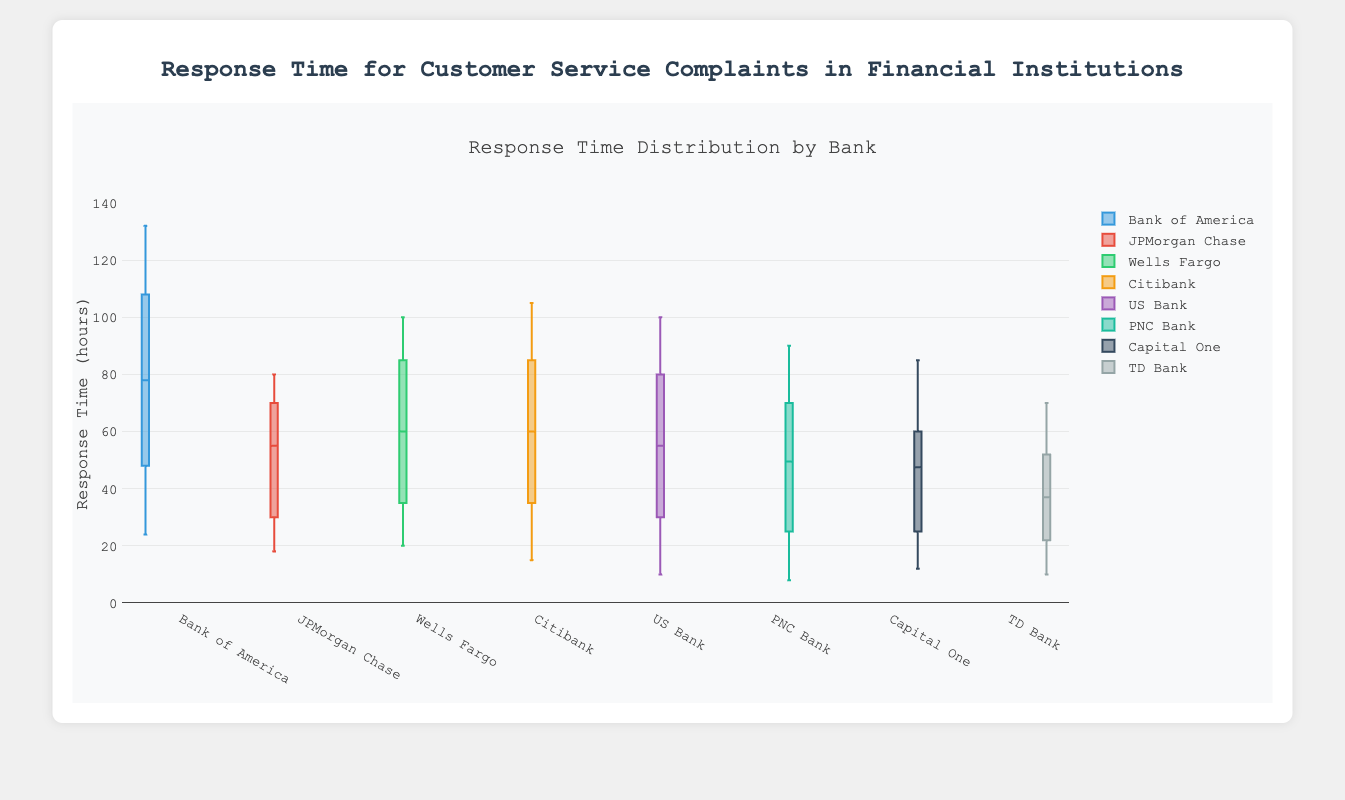How many banks are being compared in the box plot? The box plot consists of one trace for each bank, representing its response time distribution. By counting the traces, we determine that there are eight banks being compared.
Answer: Eight What is the title of the box plot? The title of the box plot is displayed at the top of the plot. It reads: "Response Time Distribution by Bank."
Answer: Response Time Distribution by Bank Which bank has the widest range of response times? To determine the bank with the widest range, compare the difference between the maximum and minimum response times for each bank. Bank of America has the widest range (from 24 to 132 hours).
Answer: Bank of America What is the median response time for Citibank? Identify the median on the box plot for Citibank, which is indicated by the central line dividing the box into two equal halves. The median response time for Citibank is 55 hours.
Answer: 55 Which bank has the shortest median response time? Compare the central lines (medians) of the boxes for all banks and identify the shortest one. TD Bank has the shortest median response time of 34 hours.
Answer: TD Bank What is the interquartile range (IQR) of JPMorgan Chase's response times? Calculate the IQR by subtracting the 1st quartile (Q1, bottom of the box) from the 3rd quartile (Q3, top of the box) in the box plot for JPMorgan Chase. The IQR is 65 - 30 = 35 hours.
Answer: 35 Which bank has the greatest number of outliers, and how many are there? Count the outliers for each bank shown as individual points outside of the whiskers. CitiBank has the most outliers, specifically 2 (at 15 and 105 hours).
Answer: CitiBank, 2 What is the maximum response time recorded for US Bank? The maximum response time is represented by the top whisker or outlier point. For US Bank, the maximum response time is 100 hours.
Answer: 100 Is the median response time of Wells Fargo greater than 60 hours? Look at the median line inside the Wells Fargo box; if it is above 60, then it is greater. The median for Wells Fargo is 55 hours, so it is not greater than 60 hours.
Answer: No Which bank shows the most consistent response time? The most consistent response time is indicated by the smallest range between the minimum and maximum response times and a smaller interquartile range. TD Bank has the narrowest range and therefore the most consistent response time.
Answer: TD Bank 